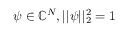<formula> <loc_0><loc_0><loc_500><loc_500>\psi \in \mathbb { C } ^ { N } , | | \psi | | _ { 2 } ^ { 2 } = 1</formula> 